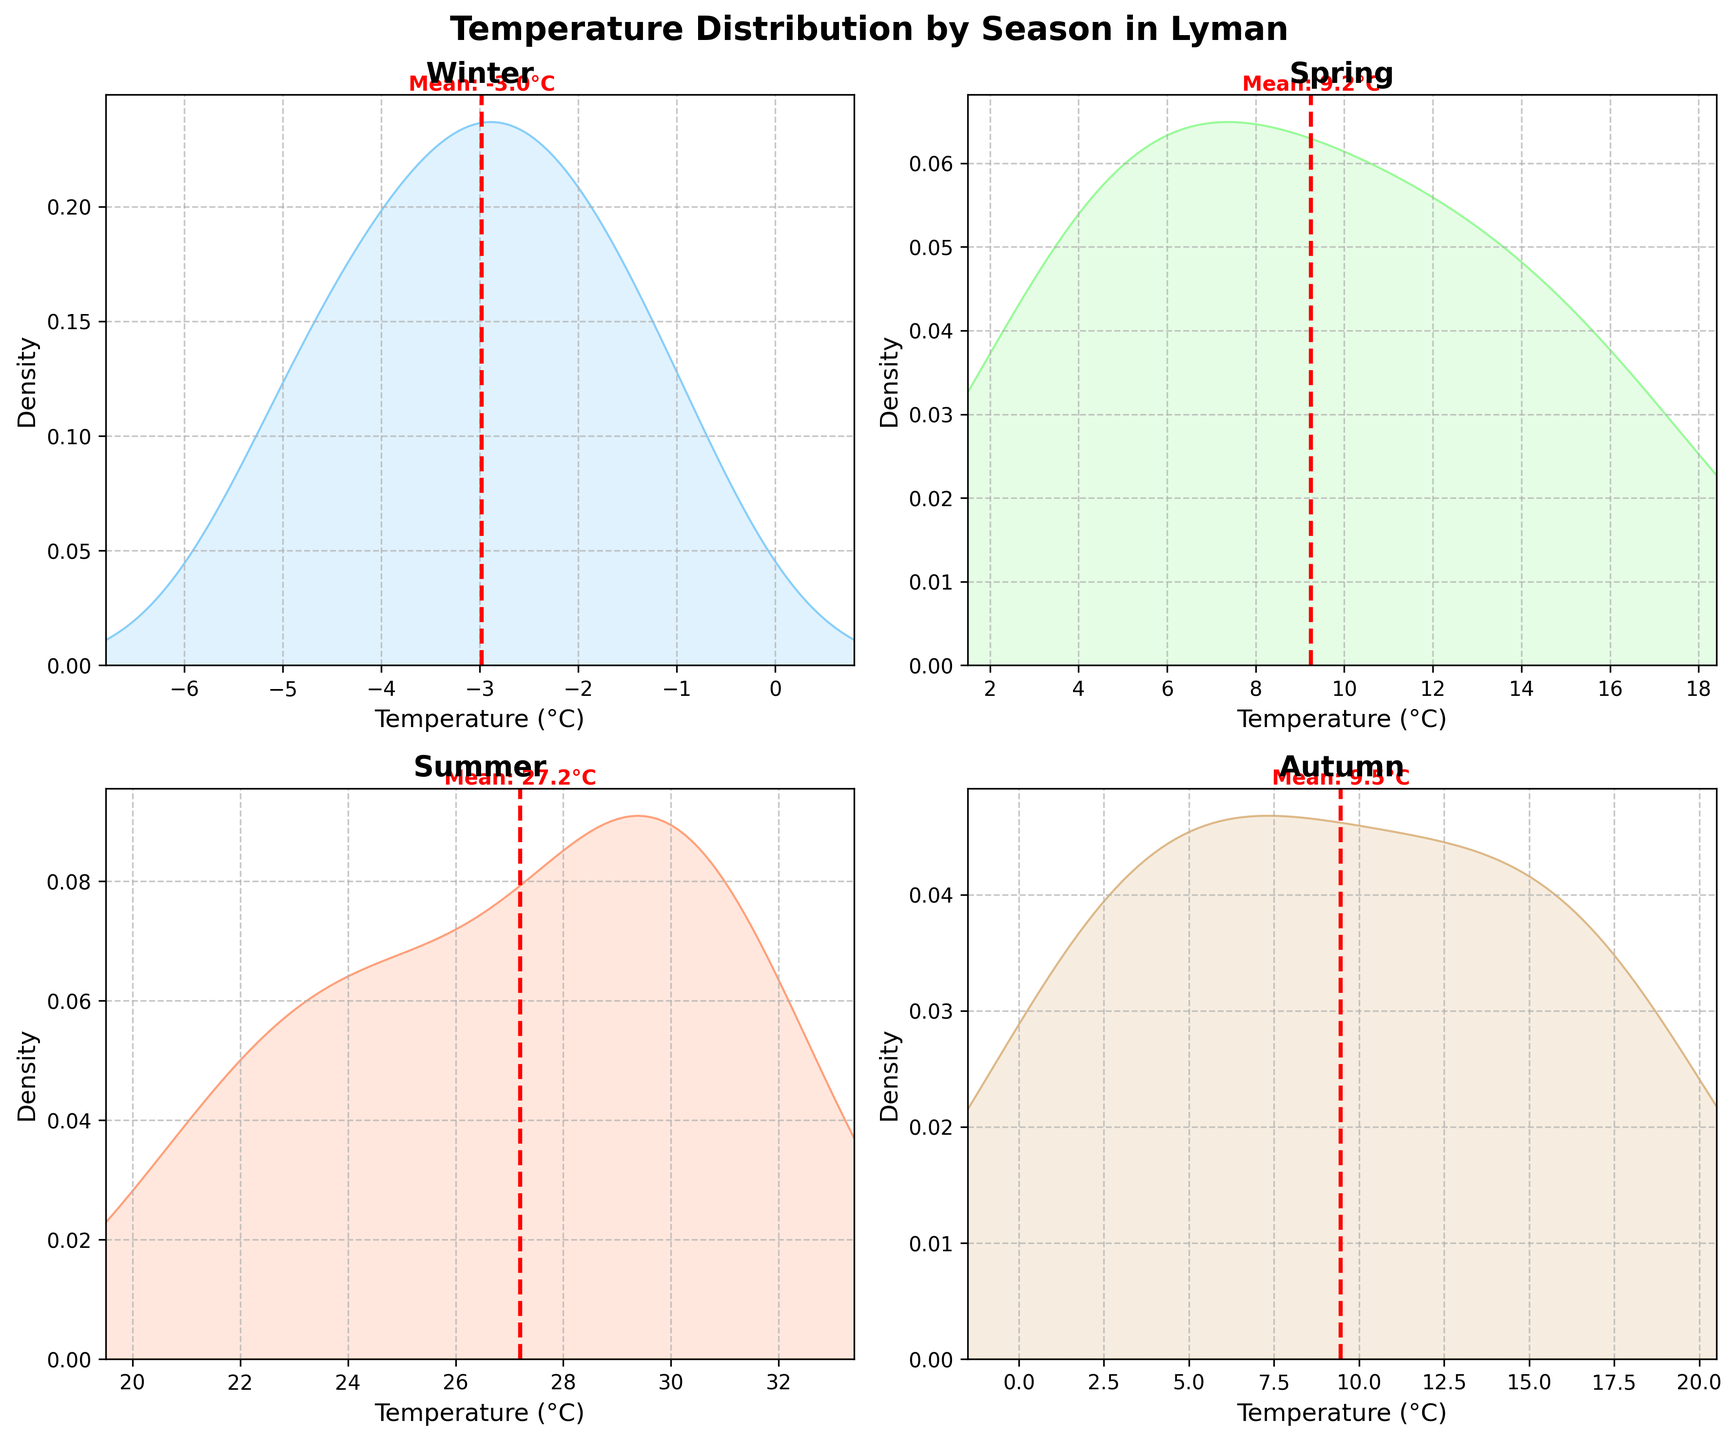What is the title of the figure? The title is usually displayed at the top center of the figure and describes what the plot is about. The title of this figure is "Temperature Distribution by Season in Lyman".
Answer: Temperature Distribution by Season in Lyman Which season has the highest mean temperature? To find the highest mean temperature, look for the red dashed lines that represent the mean temperature in each subplot. The season with the highest value of this line is Summer.
Answer: Summer What is the approximate mean temperature in Winter? In the Winter subplot, the red dashed line indicates the mean temperature. You can read the value from the x-axis where this line intersects.
Answer: -2.6°C How does the temperature range vary between Spring and Autumn? To compare the range, look at the x-axis limits for both Spring and Autumn. Spring ranges from about 1.5°C to 18.4°C, whereas Autumn ranges from about -1.5°C to 20.5°C. Spring has a narrower range compared to Autumn.
Answer: Spring: 1.5°C to 18.4°C, Autumn: -1.5°C to 20.5°C Which season shows the widest spread in temperature? The widest spread can be identified by the season with the broadest x-axis range. Autumn has the widest spread, ranging from around -1.5°C to about 20.5°C.
Answer: Autumn How are the density peaks for Summer and Winter different? Compare the peaks of the density curves in the Summer and Winter subplots. Summer has a peak at a higher temperature (around 25-30°C), while Winter peaks around lower temperatures (around -4°C).
Answer: Summer: 25-30°C, Winter: -4°C Which season has the most consistent temperature distribution? The season with the most consistent temperature distribution will have a steep peak and narrow spread. Winter appears to be the most consistent, with a more concentrated peak around a specific temperature.
Answer: Winter What is the approximate temperature range in Summer? For Summer, check the x-axis limits to find the range. Summer ranges from about 19.5°C to about 33.4°C.
Answer: 19.5°C to 33.4°C Is there any season where the mean temperature is above 30°C? The mean temperature is indicated by the red dashed line. Only Summer has a mean temperature above 30°C.
Answer: No Which season shows the largest decrease in mean temperature compared to Summer? To find the largest decrease, compare the mean temperatures indicated by the red dashed lines of Summer and other seasons. Winter has the largest difference with a mean around -2.6°C, and Summer with around 30°C. The difference is roughly 32.6°C.
Answer: Winter 